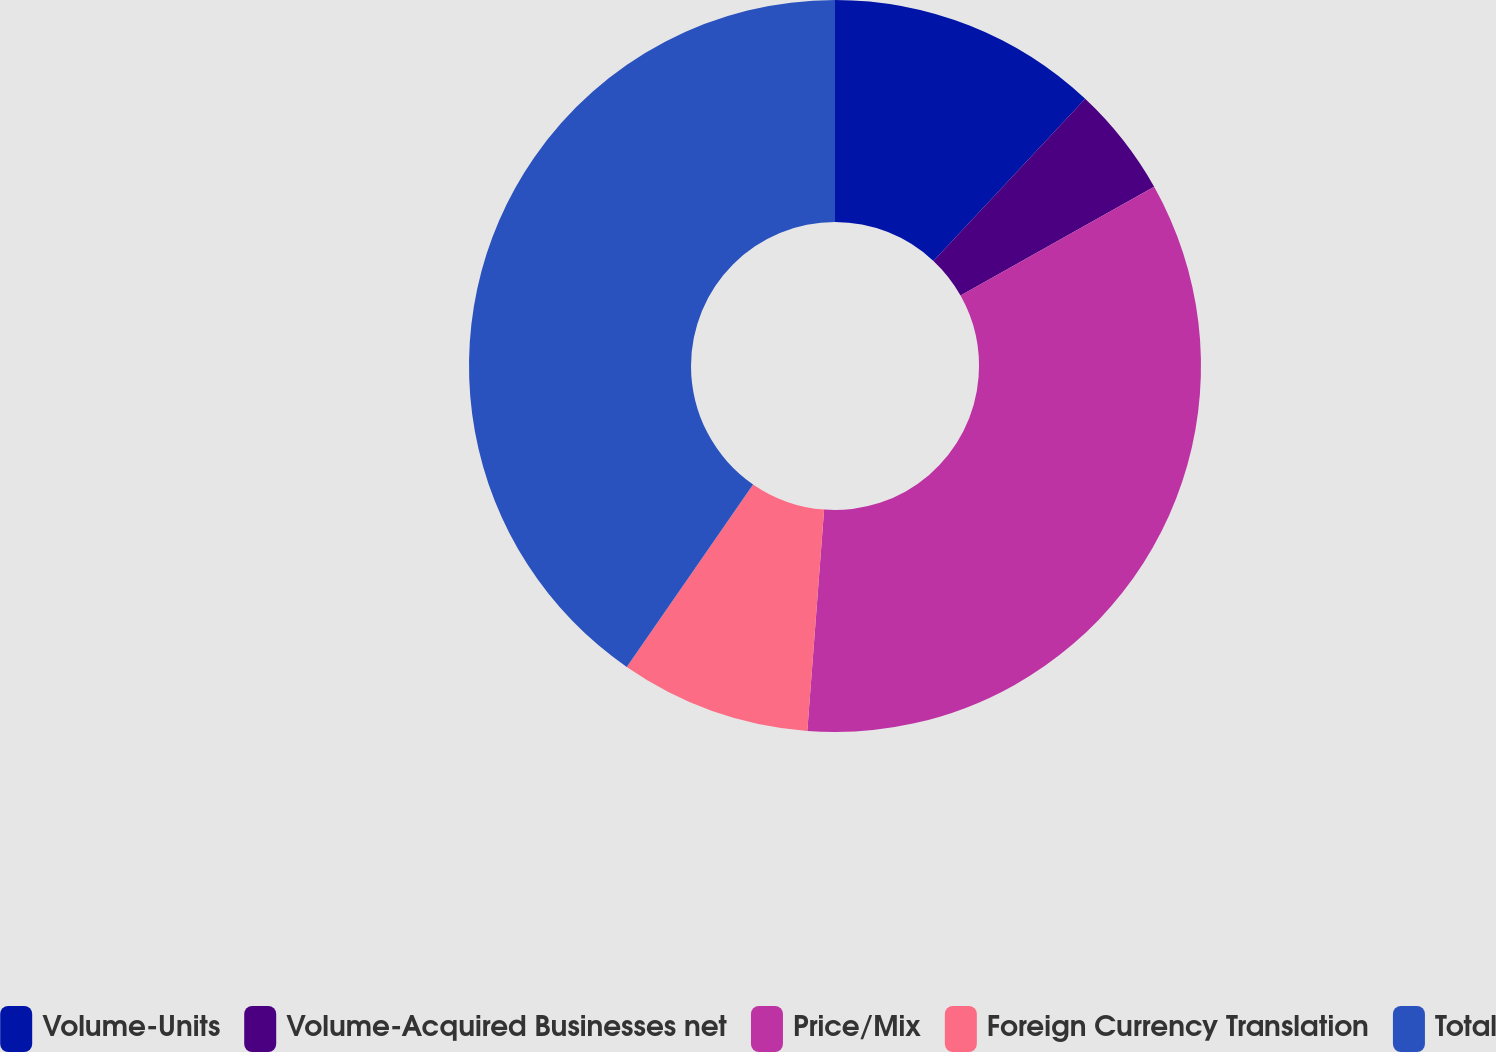<chart> <loc_0><loc_0><loc_500><loc_500><pie_chart><fcel>Volume-Units<fcel>Volume-Acquired Businesses net<fcel>Price/Mix<fcel>Foreign Currency Translation<fcel>Total<nl><fcel>11.98%<fcel>4.88%<fcel>34.35%<fcel>8.43%<fcel>40.37%<nl></chart> 